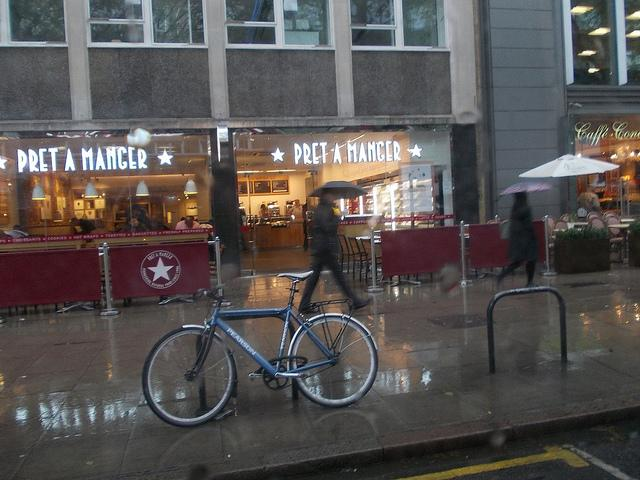What time of day is it here?

Choices:
A) midday
B) midnight
C) noon
D) twilight twilight 